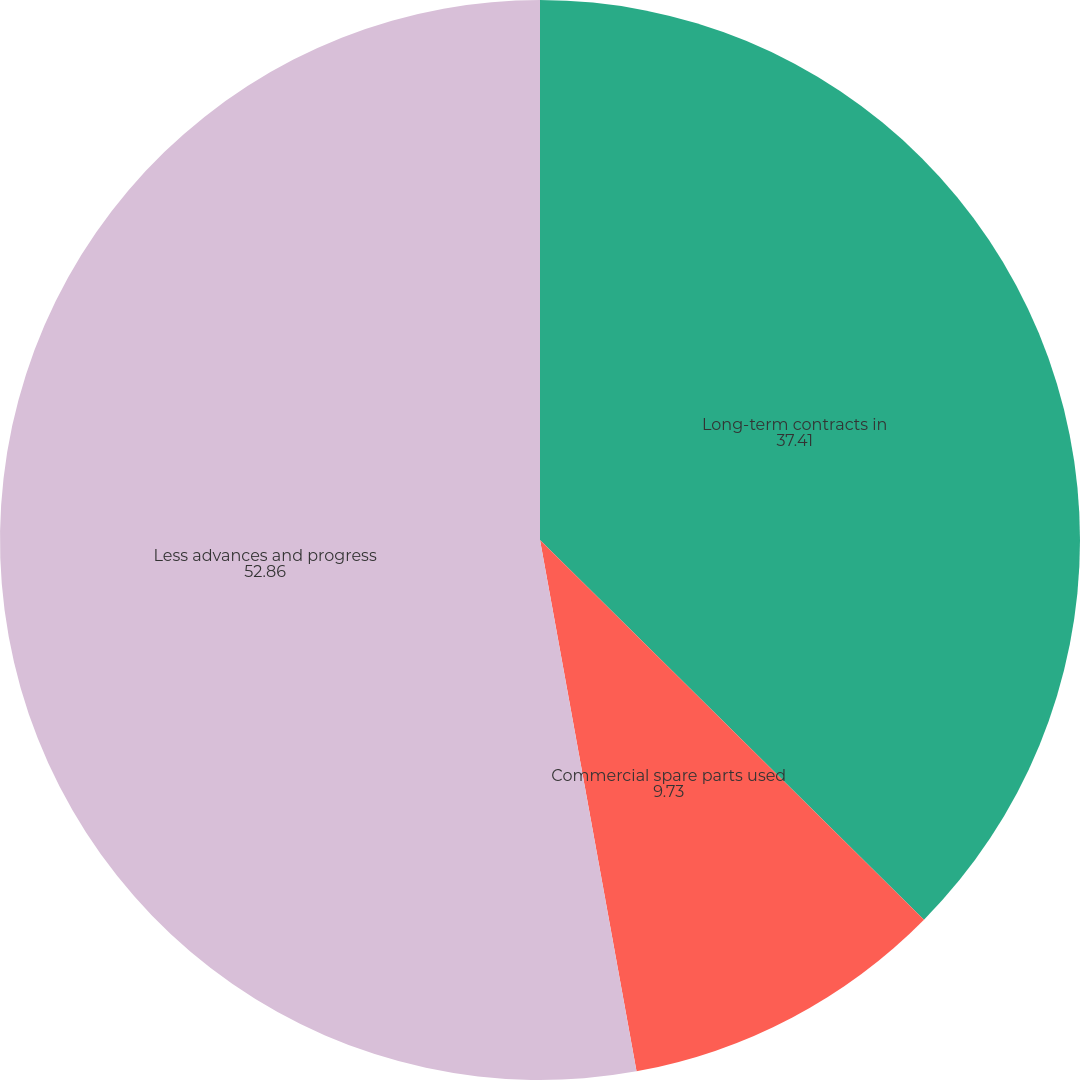<chart> <loc_0><loc_0><loc_500><loc_500><pie_chart><fcel>Long-term contracts in<fcel>Commercial spare parts used<fcel>Less advances and progress<nl><fcel>37.41%<fcel>9.73%<fcel>52.86%<nl></chart> 